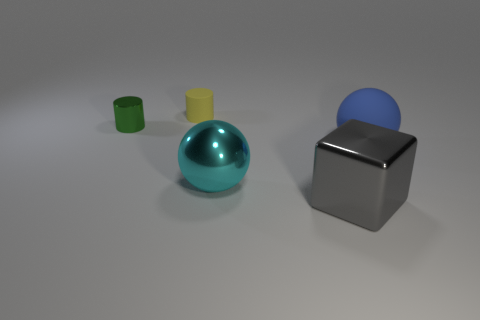Add 1 yellow blocks. How many objects exist? 6 Subtract all cubes. How many objects are left? 4 Add 1 balls. How many balls are left? 3 Add 4 gray metal things. How many gray metal things exist? 5 Subtract 0 gray balls. How many objects are left? 5 Subtract all green cylinders. Subtract all small rubber cylinders. How many objects are left? 3 